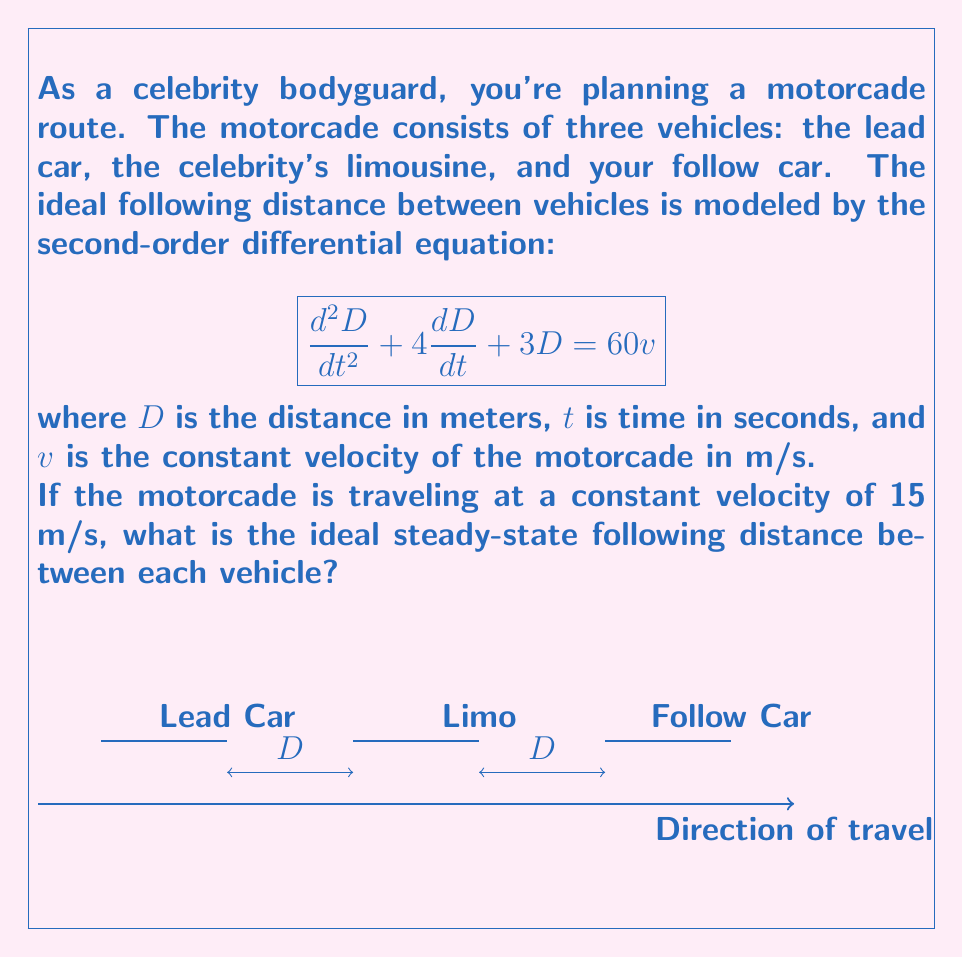Give your solution to this math problem. Let's solve this step-by-step:

1) In steady-state, the distance $D$ is constant, so its derivatives with respect to time are zero:

   $$\frac{dD}{dt} = 0, \frac{d^2D}{dt^2} = 0$$

2) Substituting these into the original differential equation:

   $$0 + 0 + 3D = 60v$$

3) Simplify:

   $$3D = 60v$$

4) Solve for $D$:

   $$D = 20v$$

5) Now, substitute the given velocity $v = 15$ m/s:

   $$D = 20 \cdot 15 = 300$$

Therefore, the ideal steady-state following distance is 300 meters.
Answer: 300 meters 